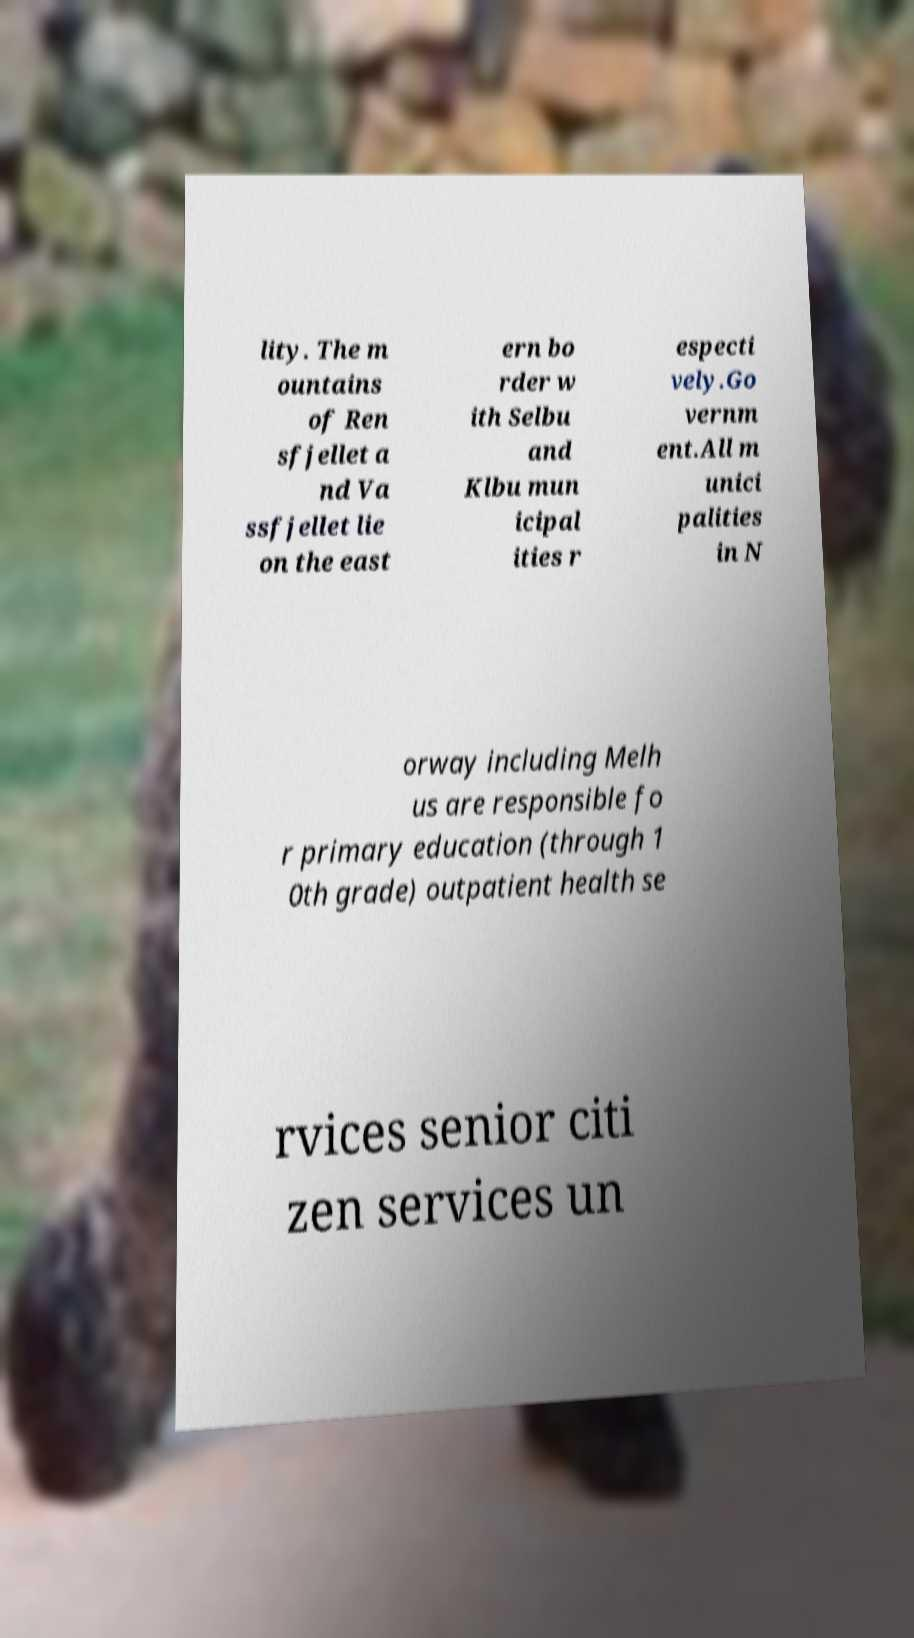Could you extract and type out the text from this image? lity. The m ountains of Ren sfjellet a nd Va ssfjellet lie on the east ern bo rder w ith Selbu and Klbu mun icipal ities r especti vely.Go vernm ent.All m unici palities in N orway including Melh us are responsible fo r primary education (through 1 0th grade) outpatient health se rvices senior citi zen services un 